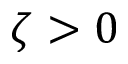Convert formula to latex. <formula><loc_0><loc_0><loc_500><loc_500>\zeta > 0</formula> 